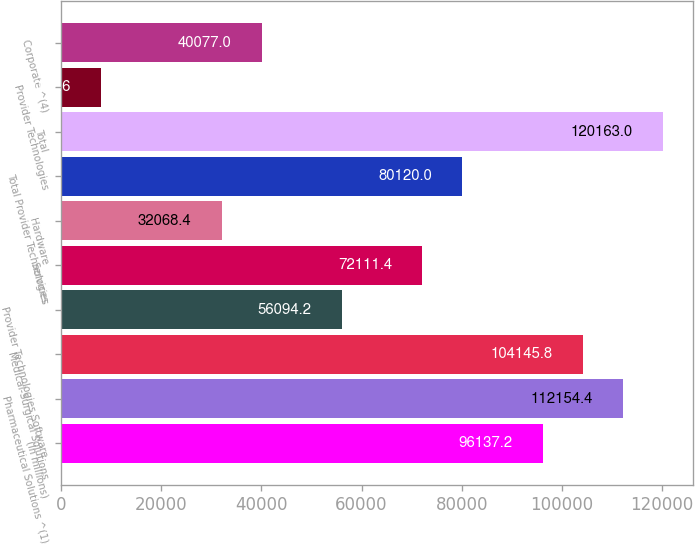Convert chart to OTSL. <chart><loc_0><loc_0><loc_500><loc_500><bar_chart><fcel>(In millions)<fcel>Pharmaceutical Solutions ^(1)<fcel>Medical-Surgical Solutions<fcel>Provider Technologies Software<fcel>Services<fcel>Hardware<fcel>Total Provider Technologies<fcel>Total<fcel>Provider Technologies<fcel>Corporate ^(4)<nl><fcel>96137.2<fcel>112154<fcel>104146<fcel>56094.2<fcel>72111.4<fcel>32068.4<fcel>80120<fcel>120163<fcel>8042.6<fcel>40077<nl></chart> 